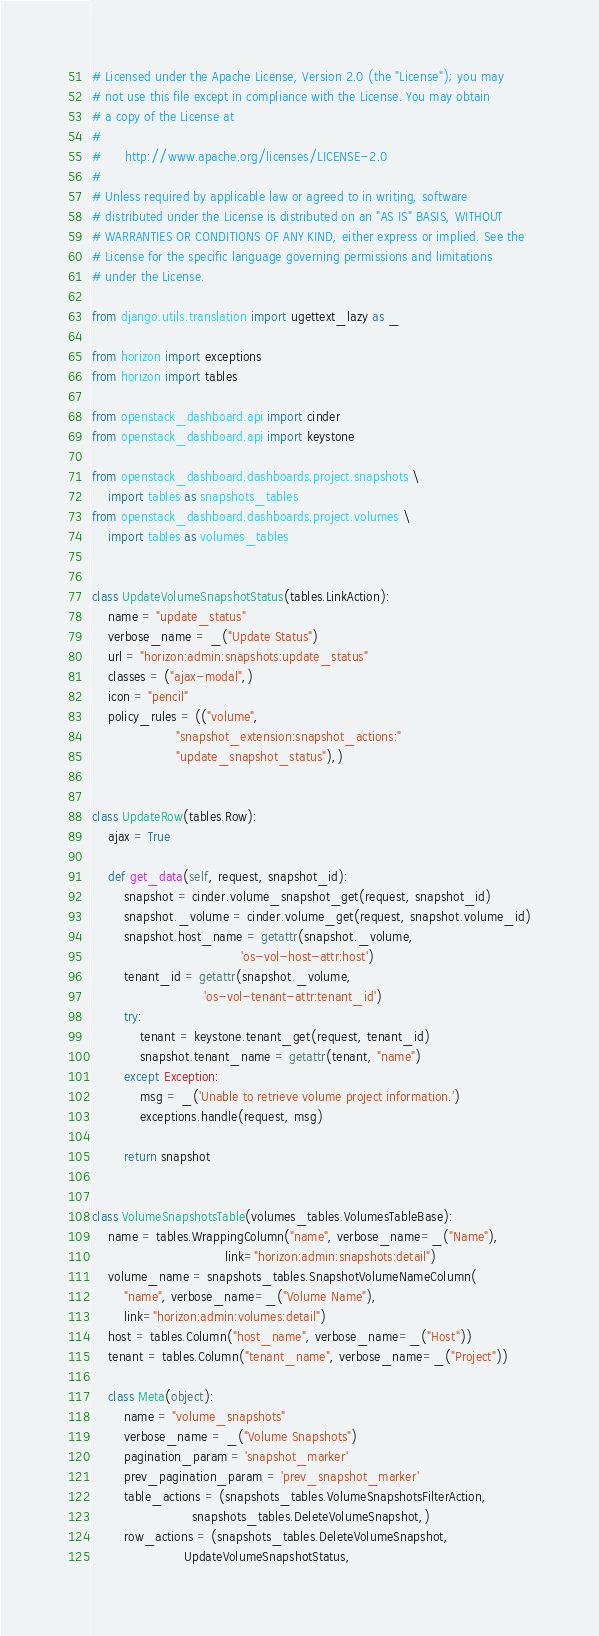Convert code to text. <code><loc_0><loc_0><loc_500><loc_500><_Python_># Licensed under the Apache License, Version 2.0 (the "License"); you may
# not use this file except in compliance with the License. You may obtain
# a copy of the License at
#
#      http://www.apache.org/licenses/LICENSE-2.0
#
# Unless required by applicable law or agreed to in writing, software
# distributed under the License is distributed on an "AS IS" BASIS, WITHOUT
# WARRANTIES OR CONDITIONS OF ANY KIND, either express or implied. See the
# License for the specific language governing permissions and limitations
# under the License.

from django.utils.translation import ugettext_lazy as _

from horizon import exceptions
from horizon import tables

from openstack_dashboard.api import cinder
from openstack_dashboard.api import keystone

from openstack_dashboard.dashboards.project.snapshots \
    import tables as snapshots_tables
from openstack_dashboard.dashboards.project.volumes \
    import tables as volumes_tables


class UpdateVolumeSnapshotStatus(tables.LinkAction):
    name = "update_status"
    verbose_name = _("Update Status")
    url = "horizon:admin:snapshots:update_status"
    classes = ("ajax-modal",)
    icon = "pencil"
    policy_rules = (("volume",
                     "snapshot_extension:snapshot_actions:"
                     "update_snapshot_status"),)


class UpdateRow(tables.Row):
    ajax = True

    def get_data(self, request, snapshot_id):
        snapshot = cinder.volume_snapshot_get(request, snapshot_id)
        snapshot._volume = cinder.volume_get(request, snapshot.volume_id)
        snapshot.host_name = getattr(snapshot._volume,
                                     'os-vol-host-attr:host')
        tenant_id = getattr(snapshot._volume,
                            'os-vol-tenant-attr:tenant_id')
        try:
            tenant = keystone.tenant_get(request, tenant_id)
            snapshot.tenant_name = getattr(tenant, "name")
        except Exception:
            msg = _('Unable to retrieve volume project information.')
            exceptions.handle(request, msg)

        return snapshot


class VolumeSnapshotsTable(volumes_tables.VolumesTableBase):
    name = tables.WrappingColumn("name", verbose_name=_("Name"),
                                 link="horizon:admin:snapshots:detail")
    volume_name = snapshots_tables.SnapshotVolumeNameColumn(
        "name", verbose_name=_("Volume Name"),
        link="horizon:admin:volumes:detail")
    host = tables.Column("host_name", verbose_name=_("Host"))
    tenant = tables.Column("tenant_name", verbose_name=_("Project"))

    class Meta(object):
        name = "volume_snapshots"
        verbose_name = _("Volume Snapshots")
        pagination_param = 'snapshot_marker'
        prev_pagination_param = 'prev_snapshot_marker'
        table_actions = (snapshots_tables.VolumeSnapshotsFilterAction,
                         snapshots_tables.DeleteVolumeSnapshot,)
        row_actions = (snapshots_tables.DeleteVolumeSnapshot,
                       UpdateVolumeSnapshotStatus,</code> 